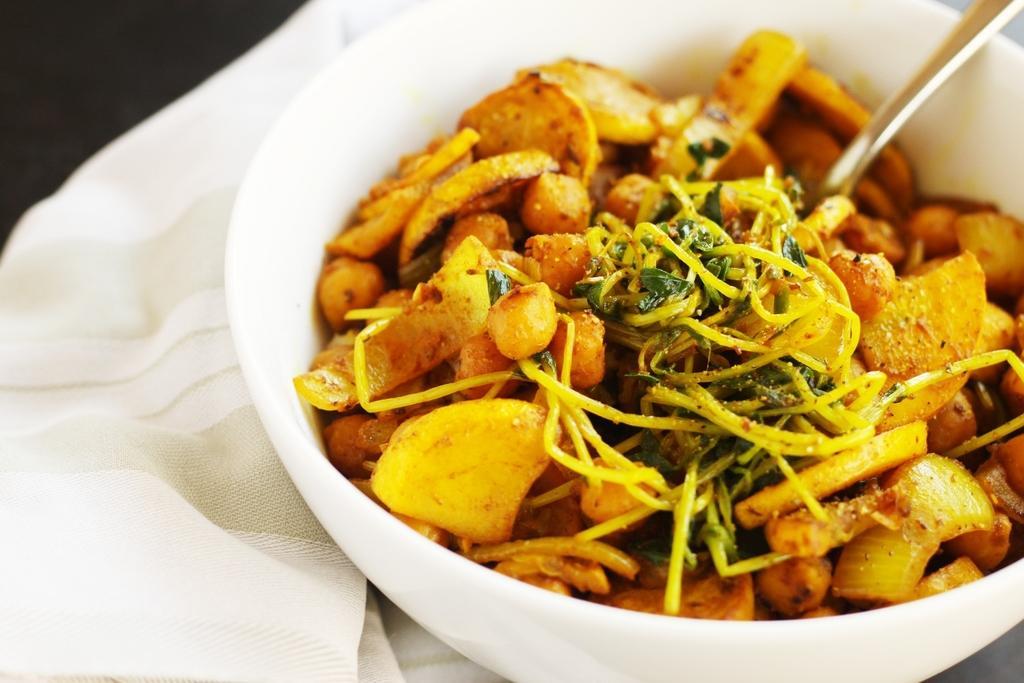Describe this image in one or two sentences. Here I can see a bowl which consists of some food item and a spoon. This bowl is placed on a white color cloth. The background is dark. 